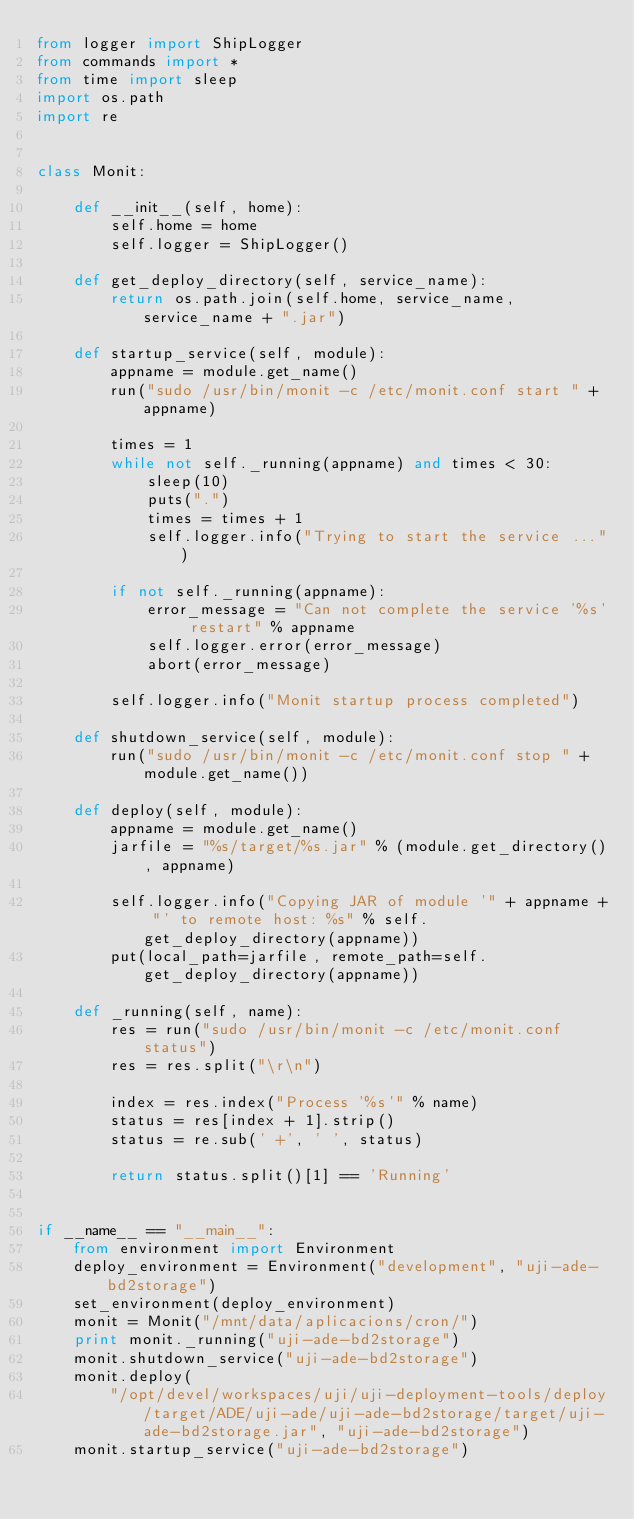Convert code to text. <code><loc_0><loc_0><loc_500><loc_500><_Python_>from logger import ShipLogger
from commands import *
from time import sleep
import os.path
import re


class Monit:

    def __init__(self, home):
        self.home = home
        self.logger = ShipLogger()

    def get_deploy_directory(self, service_name):
        return os.path.join(self.home, service_name, service_name + ".jar")

    def startup_service(self, module):
        appname = module.get_name()
        run("sudo /usr/bin/monit -c /etc/monit.conf start " + appname)

        times = 1
        while not self._running(appname) and times < 30:
            sleep(10)
            puts(".")
            times = times + 1
            self.logger.info("Trying to start the service ...")

        if not self._running(appname):
            error_message = "Can not complete the service '%s' restart" % appname
            self.logger.error(error_message)
            abort(error_message)

        self.logger.info("Monit startup process completed")

    def shutdown_service(self, module):
        run("sudo /usr/bin/monit -c /etc/monit.conf stop " + module.get_name())

    def deploy(self, module):
        appname = module.get_name()
        jarfile = "%s/target/%s.jar" % (module.get_directory(), appname)

        self.logger.info("Copying JAR of module '" + appname + "' to remote host: %s" % self.get_deploy_directory(appname))
        put(local_path=jarfile, remote_path=self.get_deploy_directory(appname))

    def _running(self, name):
        res = run("sudo /usr/bin/monit -c /etc/monit.conf status")
        res = res.split("\r\n")

        index = res.index("Process '%s'" % name)
        status = res[index + 1].strip()
        status = re.sub(' +', ' ', status)

        return status.split()[1] == 'Running'


if __name__ == "__main__":
    from environment import Environment
    deploy_environment = Environment("development", "uji-ade-bd2storage")
    set_environment(deploy_environment)
    monit = Monit("/mnt/data/aplicacions/cron/")
    print monit._running("uji-ade-bd2storage")
    monit.shutdown_service("uji-ade-bd2storage")
    monit.deploy(
        "/opt/devel/workspaces/uji/uji-deployment-tools/deploy/target/ADE/uji-ade/uji-ade-bd2storage/target/uji-ade-bd2storage.jar", "uji-ade-bd2storage")
    monit.startup_service("uji-ade-bd2storage")
</code> 